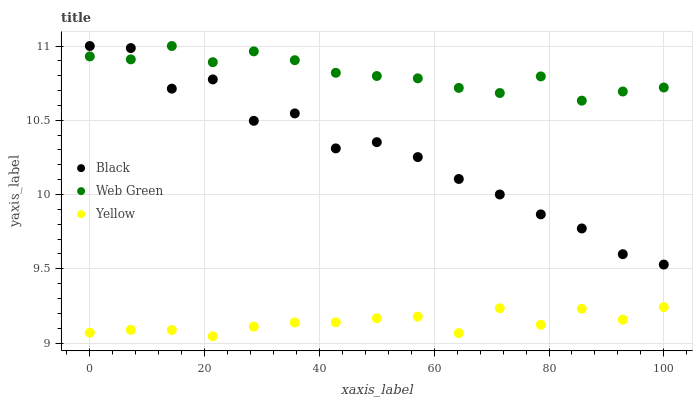Does Yellow have the minimum area under the curve?
Answer yes or no. Yes. Does Web Green have the maximum area under the curve?
Answer yes or no. Yes. Does Web Green have the minimum area under the curve?
Answer yes or no. No. Does Yellow have the maximum area under the curve?
Answer yes or no. No. Is Web Green the smoothest?
Answer yes or no. Yes. Is Black the roughest?
Answer yes or no. Yes. Is Yellow the smoothest?
Answer yes or no. No. Is Yellow the roughest?
Answer yes or no. No. Does Yellow have the lowest value?
Answer yes or no. Yes. Does Web Green have the lowest value?
Answer yes or no. No. Does Web Green have the highest value?
Answer yes or no. Yes. Does Yellow have the highest value?
Answer yes or no. No. Is Yellow less than Black?
Answer yes or no. Yes. Is Black greater than Yellow?
Answer yes or no. Yes. Does Web Green intersect Black?
Answer yes or no. Yes. Is Web Green less than Black?
Answer yes or no. No. Is Web Green greater than Black?
Answer yes or no. No. Does Yellow intersect Black?
Answer yes or no. No. 